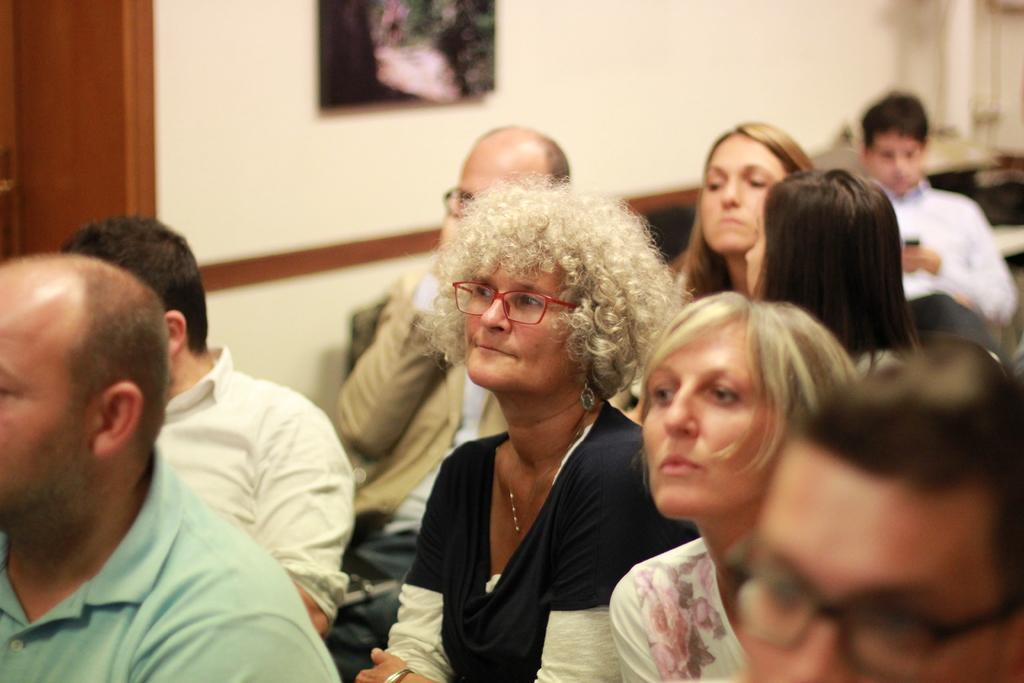Please provide a concise description of this image. Here we can see few persons. In the background we can see wall and a frame. 